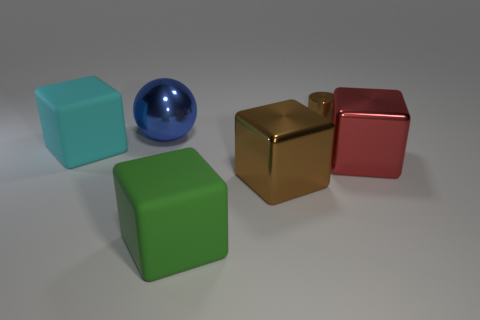What number of objects are big cyan objects or tiny yellow rubber spheres?
Offer a terse response. 1. There is a matte thing behind the brown metallic thing in front of the tiny brown metal thing; what is its shape?
Your answer should be compact. Cube. There is a metallic thing right of the small brown metallic object; is its shape the same as the big green object?
Offer a very short reply. Yes. There is a red object that is made of the same material as the brown block; what size is it?
Your answer should be compact. Large. How many objects are brown things that are behind the large blue sphere or large metallic things that are on the left side of the red metallic object?
Give a very brief answer. 3. Is the number of large spheres that are in front of the small cylinder the same as the number of tiny objects in front of the big brown cube?
Provide a succinct answer. No. What color is the big matte block behind the big green thing?
Make the answer very short. Cyan. There is a small thing; is it the same color as the large metallic cube that is on the left side of the brown cylinder?
Your response must be concise. Yes. Are there fewer tiny brown things than metallic blocks?
Ensure brevity in your answer.  Yes. Does the shiny cube on the left side of the tiny brown object have the same color as the small metallic object?
Keep it short and to the point. Yes. 